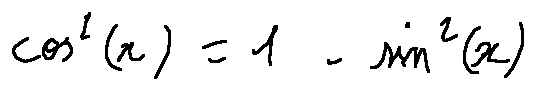Convert formula to latex. <formula><loc_0><loc_0><loc_500><loc_500>\cos ^ { 2 } ( x ) = 1 - \sin ^ { 2 } ( x )</formula> 